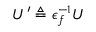Convert formula to latex. <formula><loc_0><loc_0><loc_500><loc_500>U ^ { \prime } \triangle q \epsilon _ { f } ^ { - 1 } U</formula> 